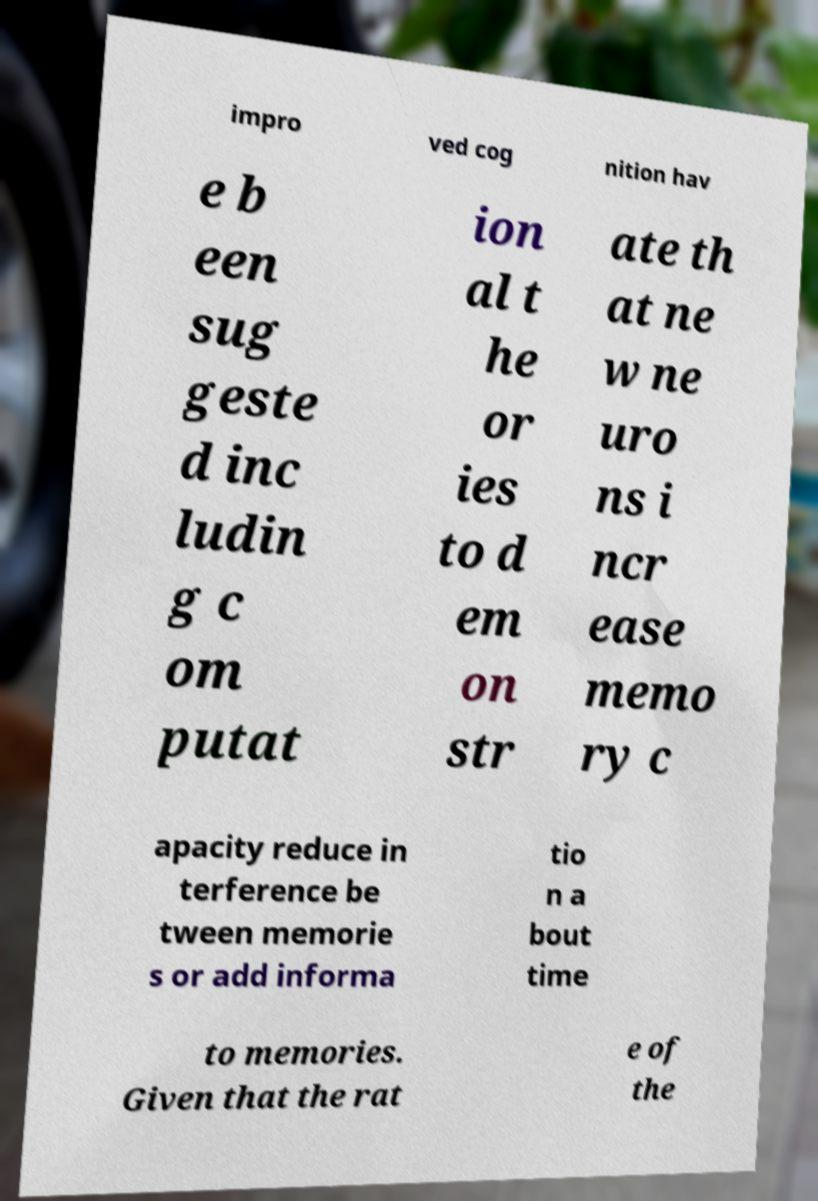There's text embedded in this image that I need extracted. Can you transcribe it verbatim? impro ved cog nition hav e b een sug geste d inc ludin g c om putat ion al t he or ies to d em on str ate th at ne w ne uro ns i ncr ease memo ry c apacity reduce in terference be tween memorie s or add informa tio n a bout time to memories. Given that the rat e of the 